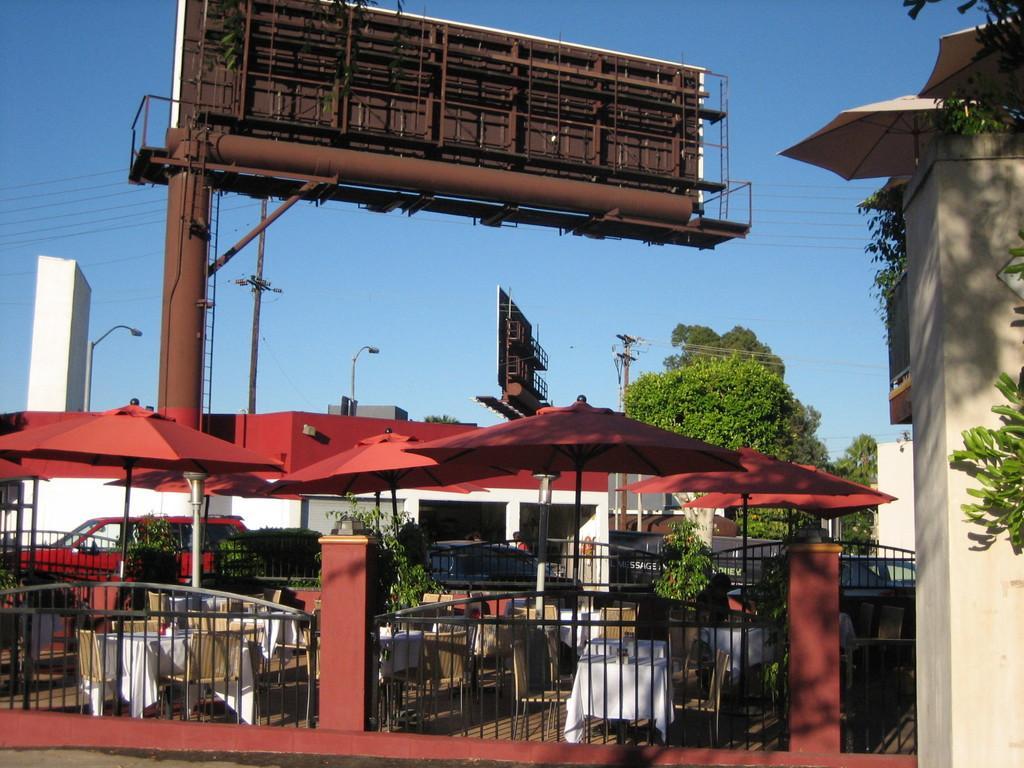Please provide a concise description of this image. In this image I see the hoardings, poles, trees, buildings and I see the fencing over here and I can also see vehicles, tables, chairs and I see the blue sky and the wires. 